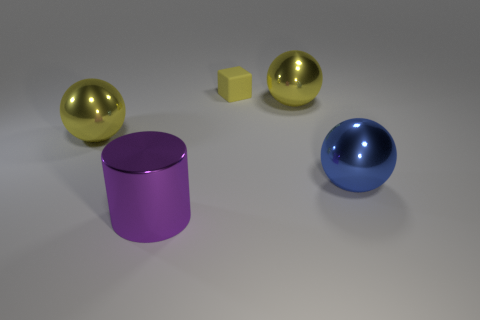Is there anything else that has the same shape as the purple metal thing?
Your answer should be very brief. No. Is there anything else that has the same size as the rubber block?
Offer a terse response. No. There is a yellow block; are there any things to the right of it?
Keep it short and to the point. Yes. Do the rubber object and the yellow metal thing that is left of the large cylinder have the same shape?
Give a very brief answer. No. What number of things are either large yellow metal objects that are on the right side of the purple thing or small purple rubber spheres?
Offer a terse response. 1. Is there any other thing that has the same material as the small yellow object?
Ensure brevity in your answer.  No. How many big metal spheres are left of the yellow rubber block and on the right side of the big purple shiny cylinder?
Keep it short and to the point. 0. What number of objects are either large objects that are right of the large purple cylinder or large yellow metallic balls on the left side of the small rubber block?
Your answer should be compact. 3. How many other objects are the same shape as the big blue object?
Keep it short and to the point. 2. There is a big metallic sphere to the left of the small yellow matte thing; is its color the same as the tiny block?
Provide a succinct answer. Yes. 